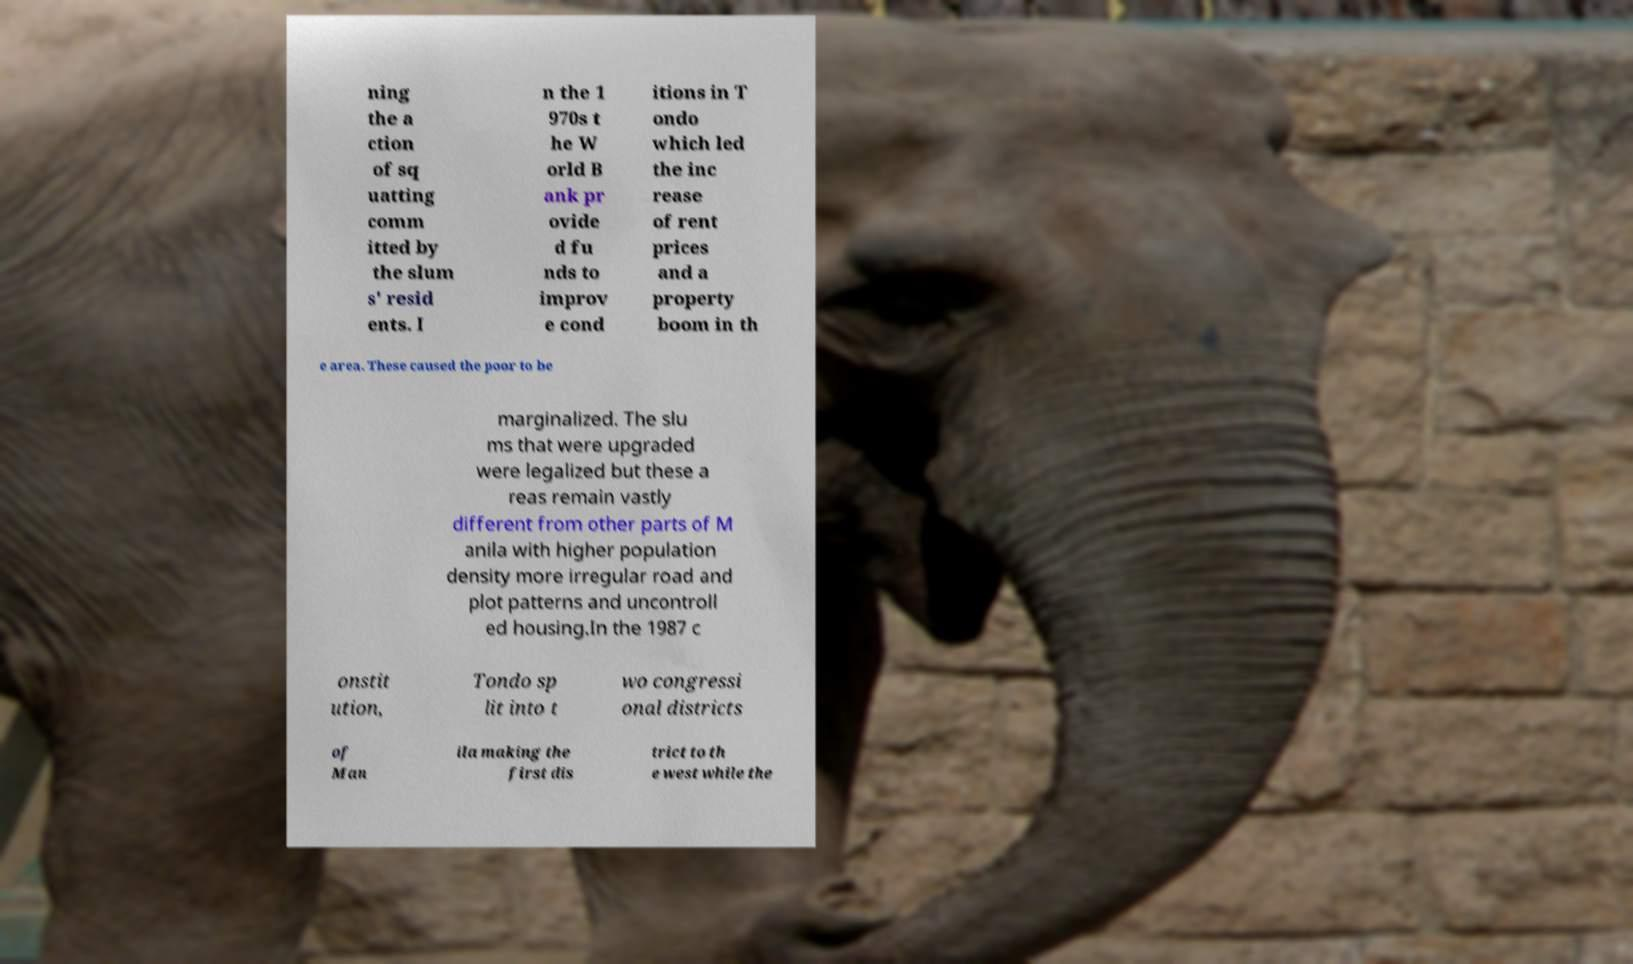Could you extract and type out the text from this image? ning the a ction of sq uatting comm itted by the slum s' resid ents. I n the 1 970s t he W orld B ank pr ovide d fu nds to improv e cond itions in T ondo which led the inc rease of rent prices and a property boom in th e area. These caused the poor to be marginalized. The slu ms that were upgraded were legalized but these a reas remain vastly different from other parts of M anila with higher population density more irregular road and plot patterns and uncontroll ed housing.In the 1987 c onstit ution, Tondo sp lit into t wo congressi onal districts of Man ila making the first dis trict to th e west while the 